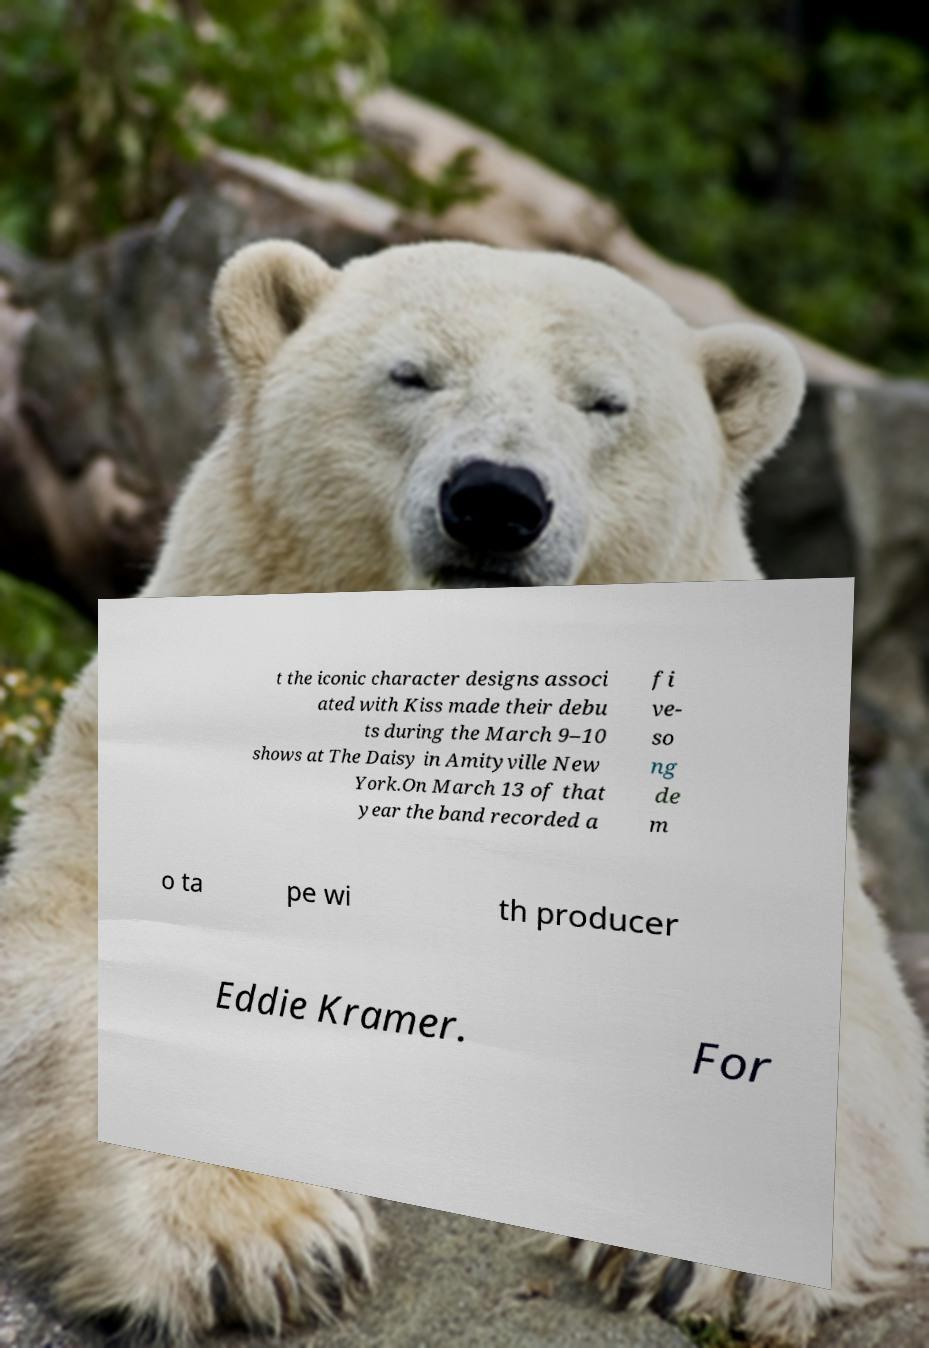Please identify and transcribe the text found in this image. t the iconic character designs associ ated with Kiss made their debu ts during the March 9–10 shows at The Daisy in Amityville New York.On March 13 of that year the band recorded a fi ve- so ng de m o ta pe wi th producer Eddie Kramer. For 